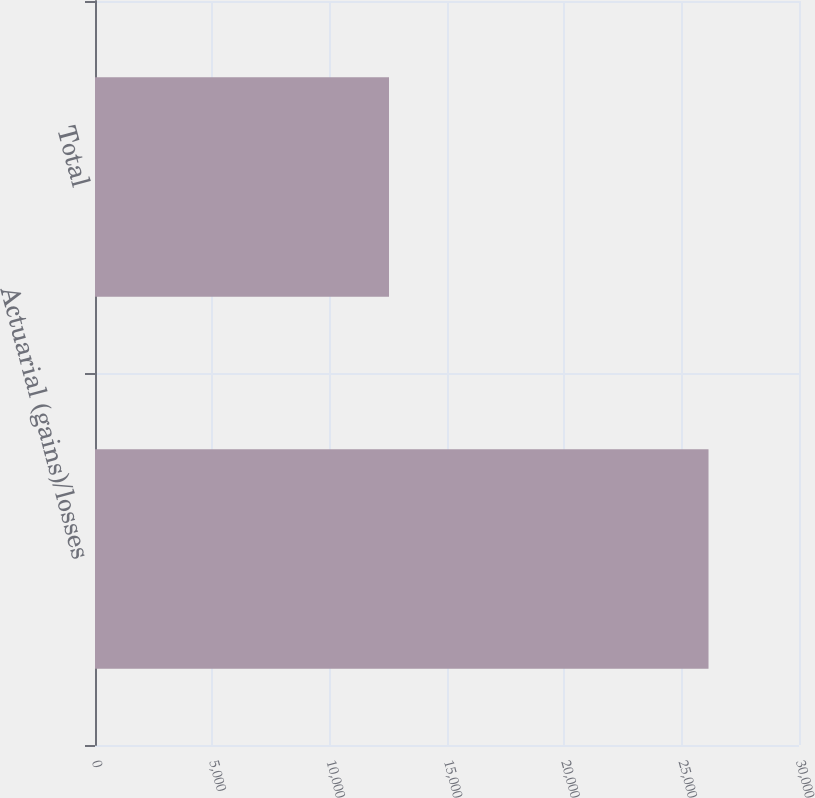<chart> <loc_0><loc_0><loc_500><loc_500><bar_chart><fcel>Actuarial (gains)/losses<fcel>Total<nl><fcel>26144<fcel>12529<nl></chart> 